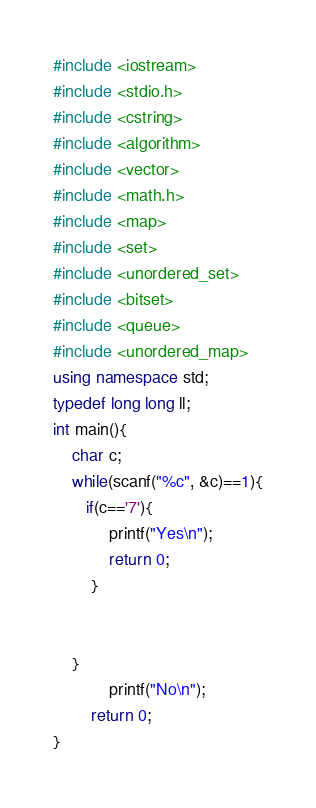<code> <loc_0><loc_0><loc_500><loc_500><_C++_>#include <iostream>
#include <stdio.h>
#include <cstring>
#include <algorithm>
#include <vector>
#include <math.h>
#include <map>
#include <set>
#include <unordered_set>
#include <bitset>
#include <queue>
#include <unordered_map>
using namespace std;
typedef long long ll;
int main(){
    char c;
    while(scanf("%c", &c)==1){
       if(c=='7'){
            printf("Yes\n");
            return 0;
        }


    }
            printf("No\n"); 
        return 0;
}</code> 